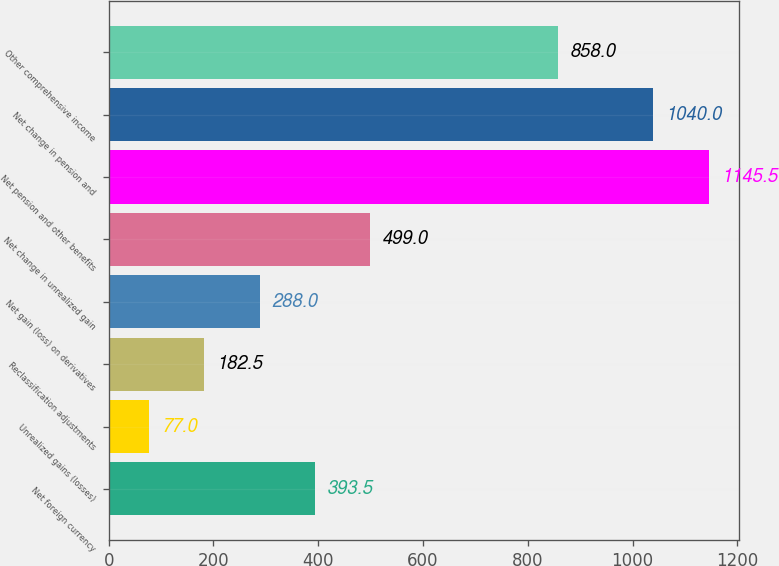Convert chart to OTSL. <chart><loc_0><loc_0><loc_500><loc_500><bar_chart><fcel>Net foreign currency<fcel>Unrealized gains (losses)<fcel>Reclassification adjustments<fcel>Net gain (loss) on derivatives<fcel>Net change in unrealized gain<fcel>Net pension and other benefits<fcel>Net change in pension and<fcel>Other comprehensive income<nl><fcel>393.5<fcel>77<fcel>182.5<fcel>288<fcel>499<fcel>1145.5<fcel>1040<fcel>858<nl></chart> 